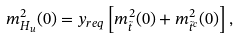<formula> <loc_0><loc_0><loc_500><loc_500>m _ { H _ { u } } ^ { 2 } ( 0 ) = y _ { r e q } \left [ m _ { \tilde { t } } ^ { 2 } ( 0 ) + m _ { \tilde { t } ^ { c } } ^ { 2 } ( 0 ) \right ] ,</formula> 